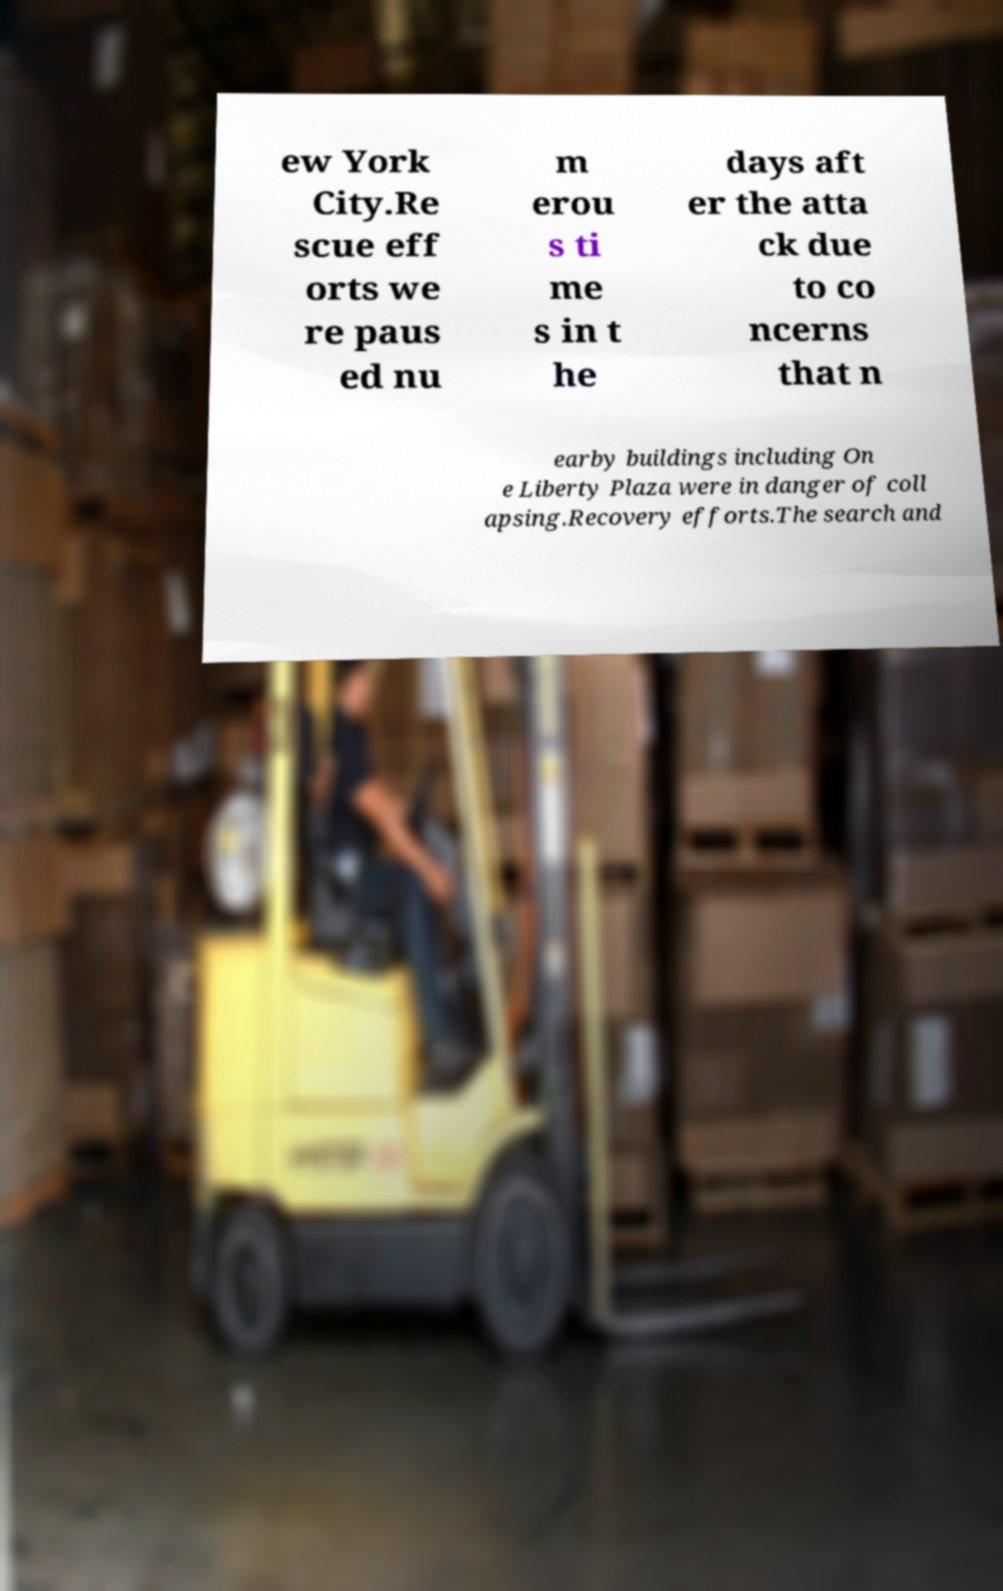I need the written content from this picture converted into text. Can you do that? ew York City.Re scue eff orts we re paus ed nu m erou s ti me s in t he days aft er the atta ck due to co ncerns that n earby buildings including On e Liberty Plaza were in danger of coll apsing.Recovery efforts.The search and 